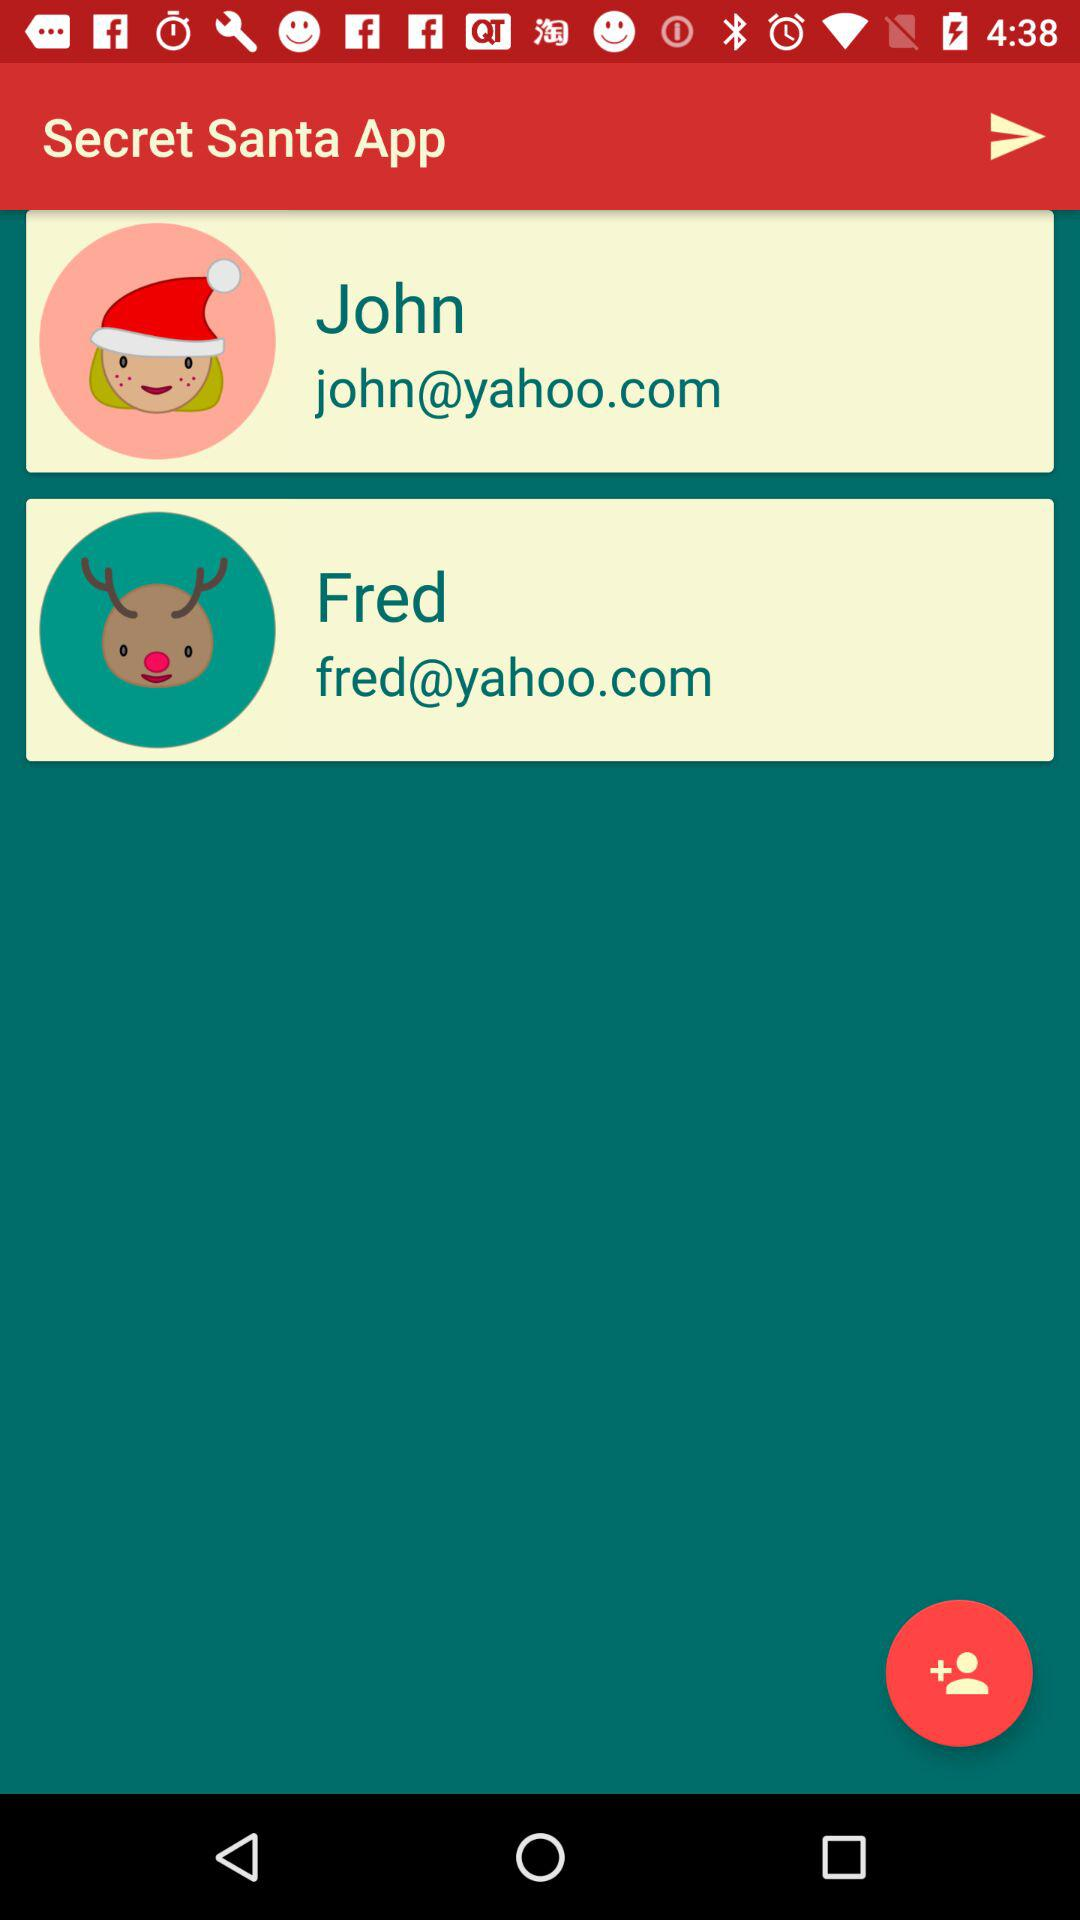What's Fred's Yahoo email address? Fred's Yahoo email address is fred@yahoo.com. 